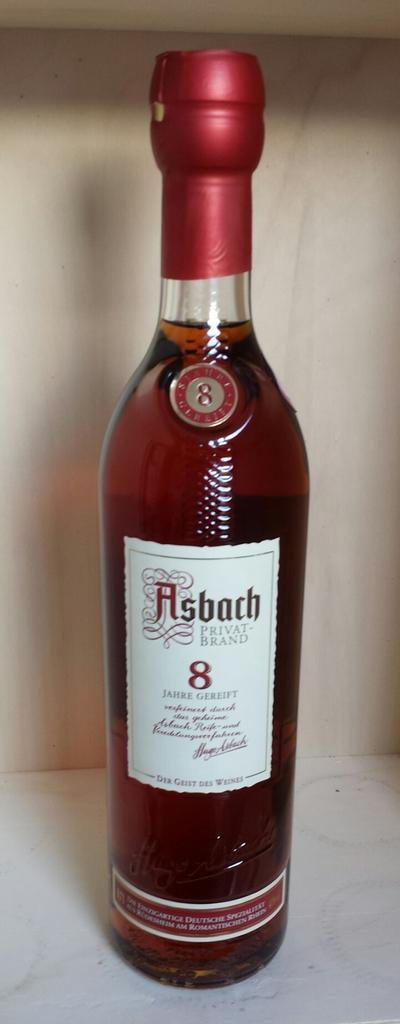How many years is the beverage?
Provide a succinct answer. 8. What is the brand?
Your answer should be very brief. Asbach. 